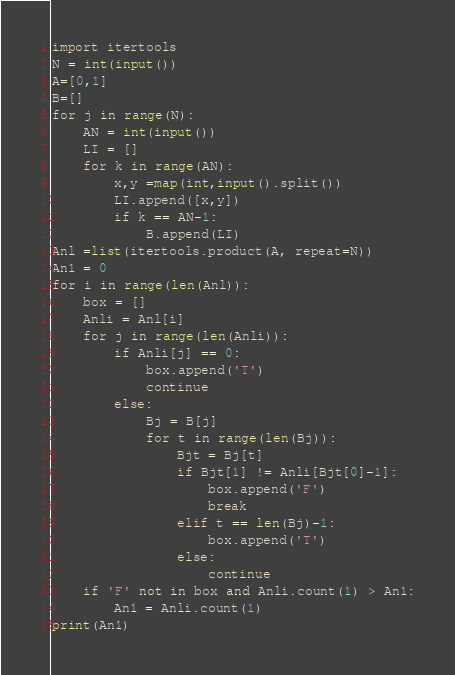Convert code to text. <code><loc_0><loc_0><loc_500><loc_500><_Python_>import itertools
N = int(input())
A=[0,1]
B=[]
for j in range(N):
    AN = int(input())
    LI = []
    for k in range(AN):
        x,y =map(int,input().split())
        LI.append([x,y])
        if k == AN-1:
            B.append(LI)
Anl =list(itertools.product(A, repeat=N))
An1 = 0
for i in range(len(Anl)):
    box = []
    Anli = Anl[i]
    for j in range(len(Anli)):
        if Anli[j] == 0:
            box.append('T')
            continue
        else:
            Bj = B[j]
            for t in range(len(Bj)):
                Bjt = Bj[t]
                if Bjt[1] != Anli[Bjt[0]-1]:
                    box.append('F')
                    break
                elif t == len(Bj)-1:
                    box.append('T')
                else:
                    continue
    if 'F' not in box and Anli.count(1) > An1:
        An1 = Anli.count(1)
print(An1)</code> 